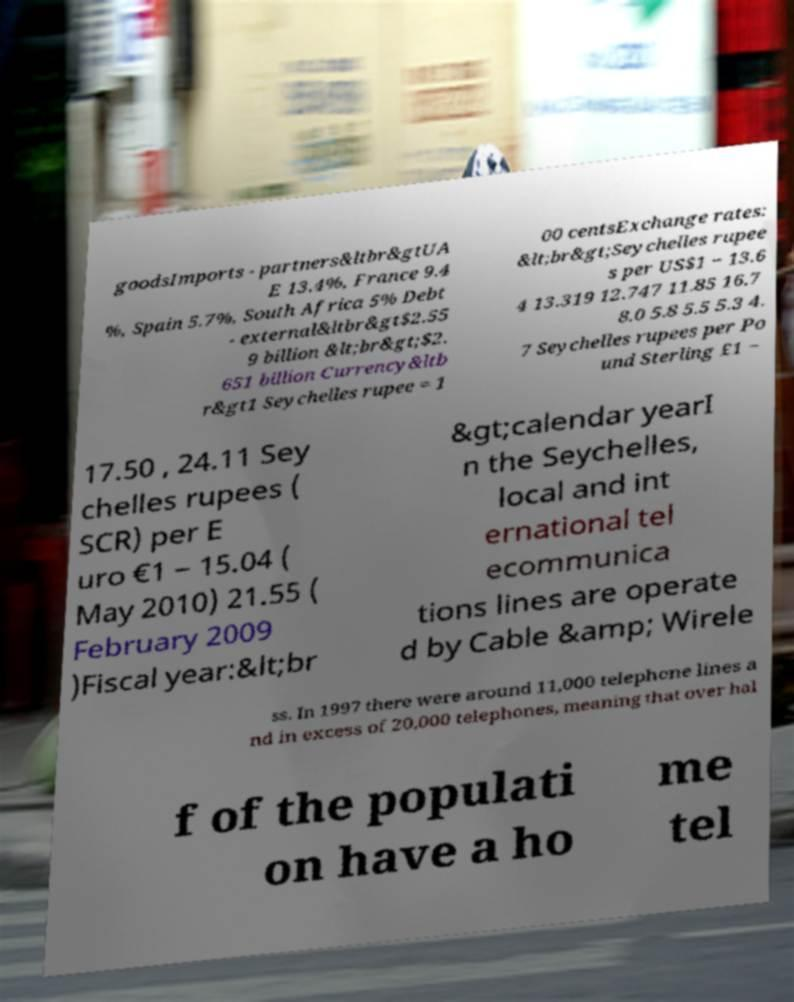Please read and relay the text visible in this image. What does it say? goodsImports - partners&ltbr&gtUA E 13.4%, France 9.4 %, Spain 5.7%, South Africa 5% Debt - external&ltbr&gt$2.55 9 billion &lt;br&gt;$2. 651 billion Currency&ltb r&gt1 Seychelles rupee = 1 00 centsExchange rates: &lt;br&gt;Seychelles rupee s per US$1 − 13.6 4 13.319 12.747 11.85 16.7 8.0 5.8 5.5 5.3 4. 7 Seychelles rupees per Po und Sterling £1 − 17.50 , 24.11 Sey chelles rupees ( SCR) per E uro €1 − 15.04 ( May 2010) 21.55 ( February 2009 )Fiscal year:&lt;br &gt;calendar yearI n the Seychelles, local and int ernational tel ecommunica tions lines are operate d by Cable &amp; Wirele ss. In 1997 there were around 11,000 telephone lines a nd in excess of 20,000 telephones, meaning that over hal f of the populati on have a ho me tel 